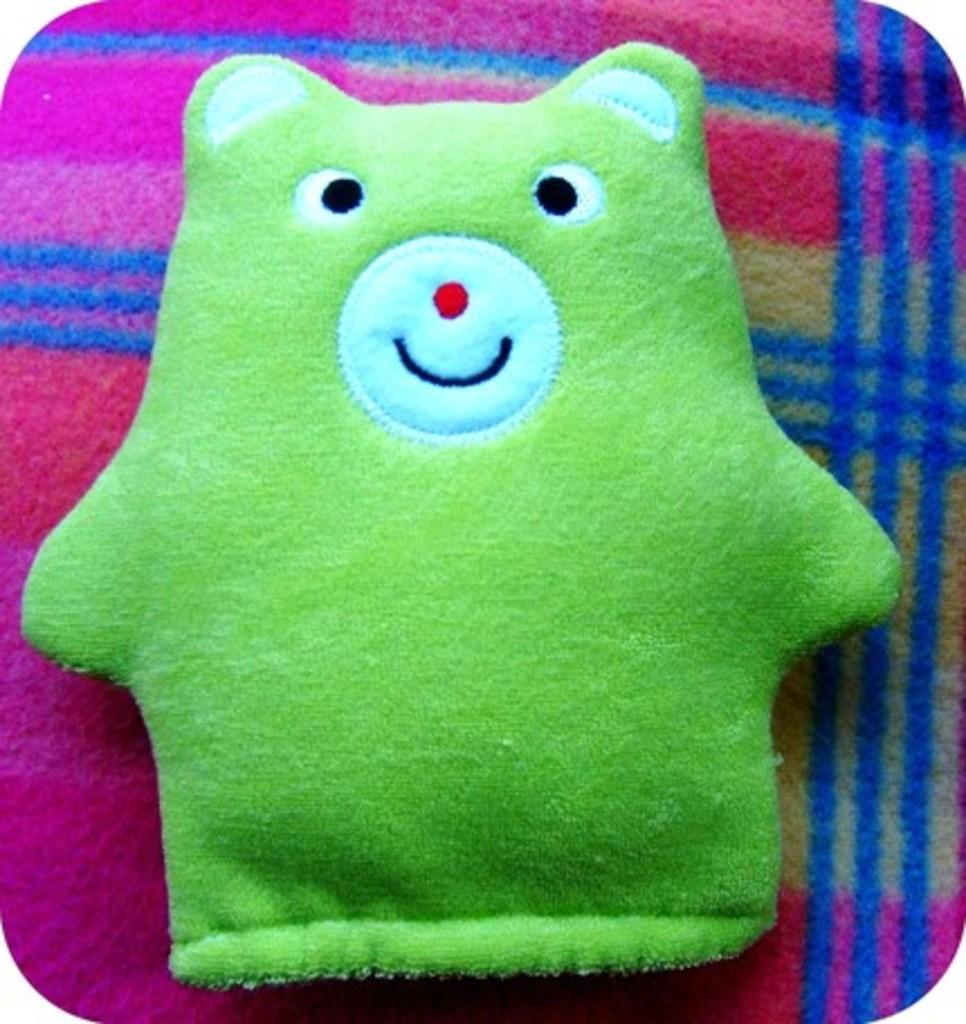What object can be seen in the image? There is a toy in the image. What is the toy placed on? The toy is on a multi-color cloth. What time is it in the image? The time is not visible or mentioned in the image, so it cannot be determined. 